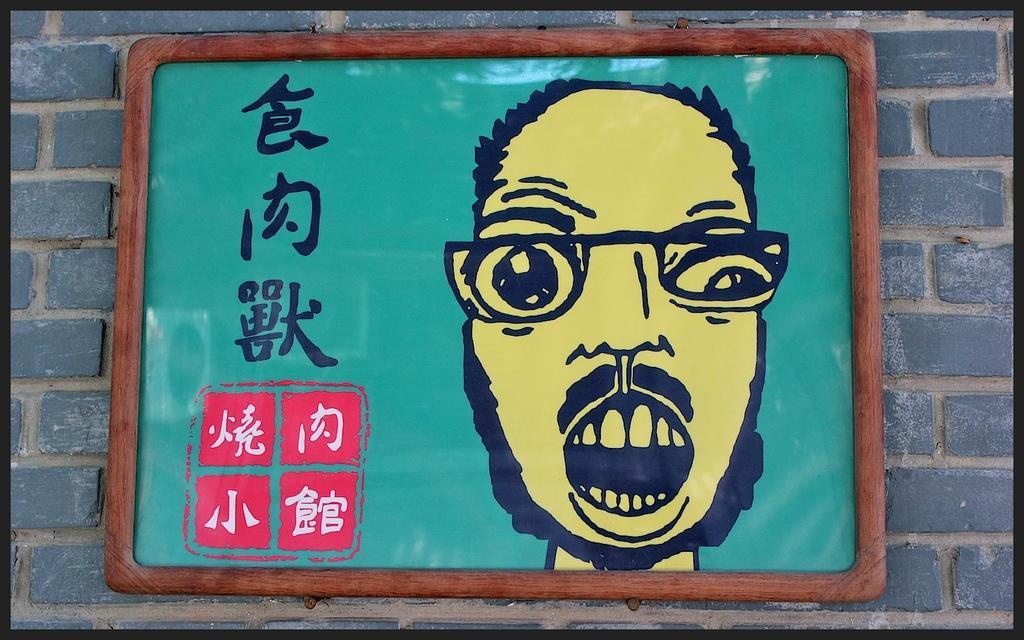Can you describe this image briefly? In the center of the picture there is a frame attached to a wall. In the frame there is text and human a face. The picture has black border. 